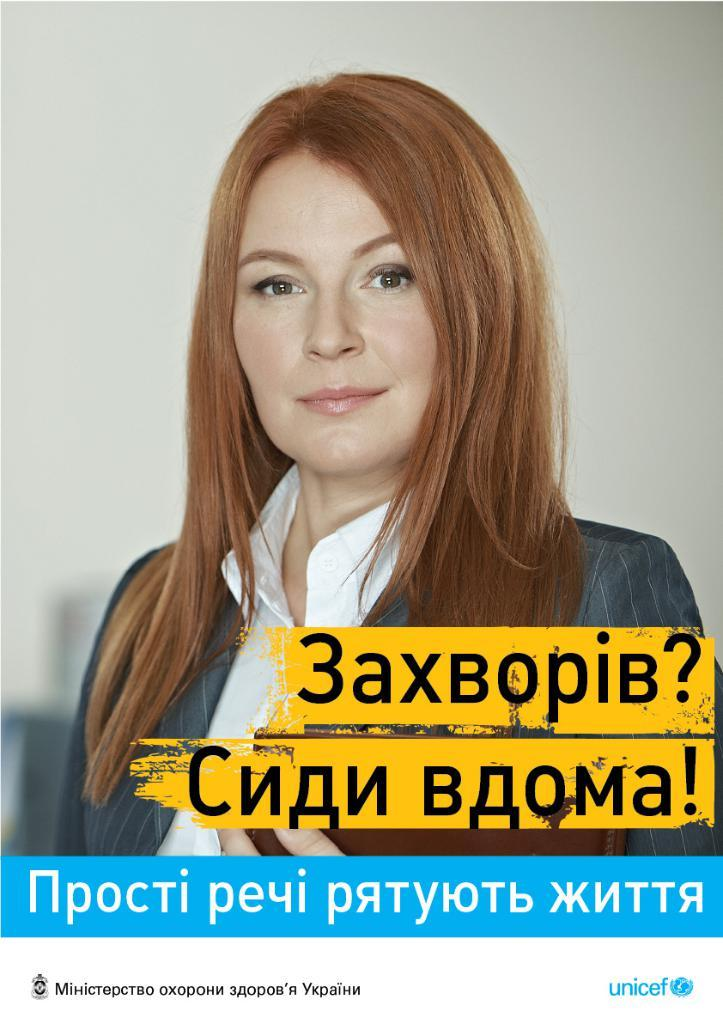Who is the main subject in the image? There is a woman in the image. What is the color of the woman's hair? The woman has brown hair. What is the woman wearing on her upper body? The woman is wearing a white shirt and a coat. What is the woman holding in her hand? The woman is holding a file in her hand. What type of argument is the woman having with the caption in the image? There is no caption present in the image, and therefore no argument can be observed. 